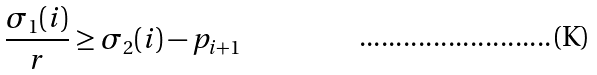<formula> <loc_0><loc_0><loc_500><loc_500>\frac { \sigma _ { 1 } ( i ) } { r } \geq \sigma _ { 2 } ( i ) - p _ { i + 1 }</formula> 